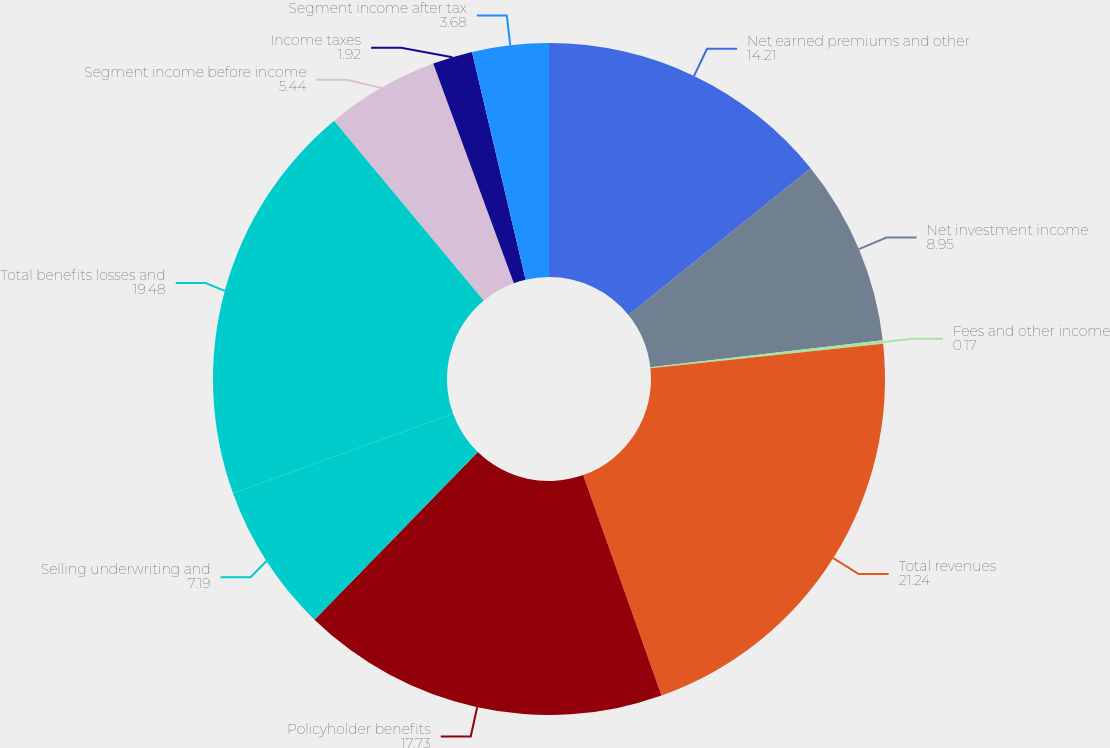Convert chart. <chart><loc_0><loc_0><loc_500><loc_500><pie_chart><fcel>Net earned premiums and other<fcel>Net investment income<fcel>Fees and other income<fcel>Total revenues<fcel>Policyholder benefits<fcel>Selling underwriting and<fcel>Total benefits losses and<fcel>Segment income before income<fcel>Income taxes<fcel>Segment income after tax<nl><fcel>14.21%<fcel>8.95%<fcel>0.17%<fcel>21.24%<fcel>17.73%<fcel>7.19%<fcel>19.48%<fcel>5.44%<fcel>1.92%<fcel>3.68%<nl></chart> 